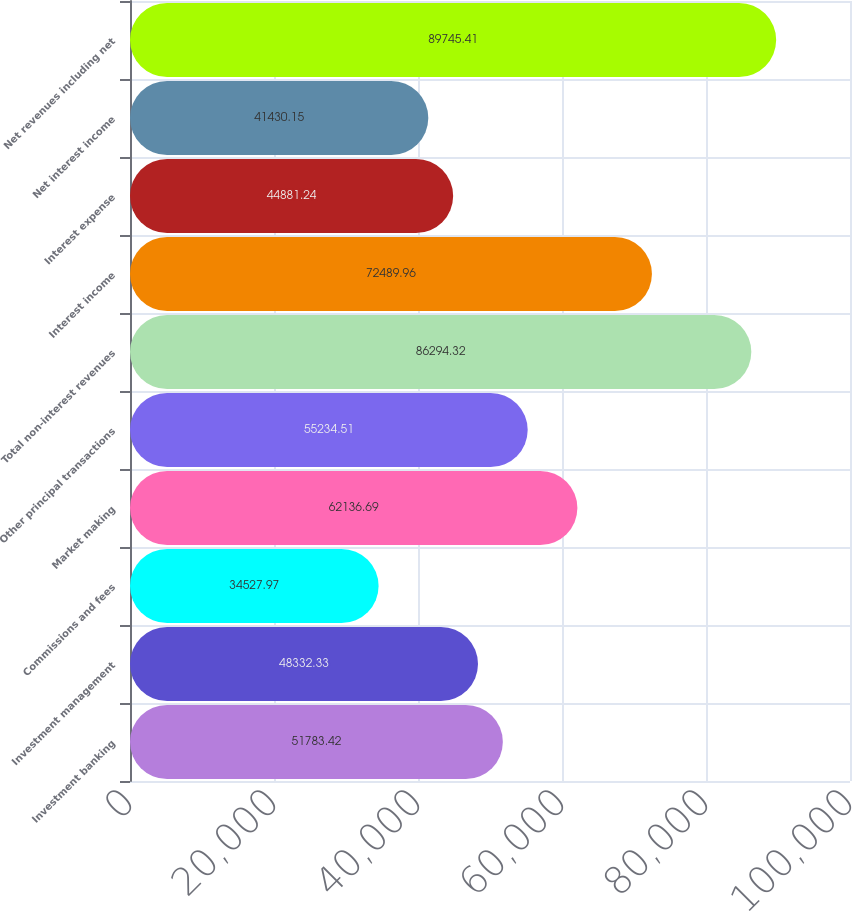<chart> <loc_0><loc_0><loc_500><loc_500><bar_chart><fcel>Investment banking<fcel>Investment management<fcel>Commissions and fees<fcel>Market making<fcel>Other principal transactions<fcel>Total non-interest revenues<fcel>Interest income<fcel>Interest expense<fcel>Net interest income<fcel>Net revenues including net<nl><fcel>51783.4<fcel>48332.3<fcel>34528<fcel>62136.7<fcel>55234.5<fcel>86294.3<fcel>72490<fcel>44881.2<fcel>41430.2<fcel>89745.4<nl></chart> 